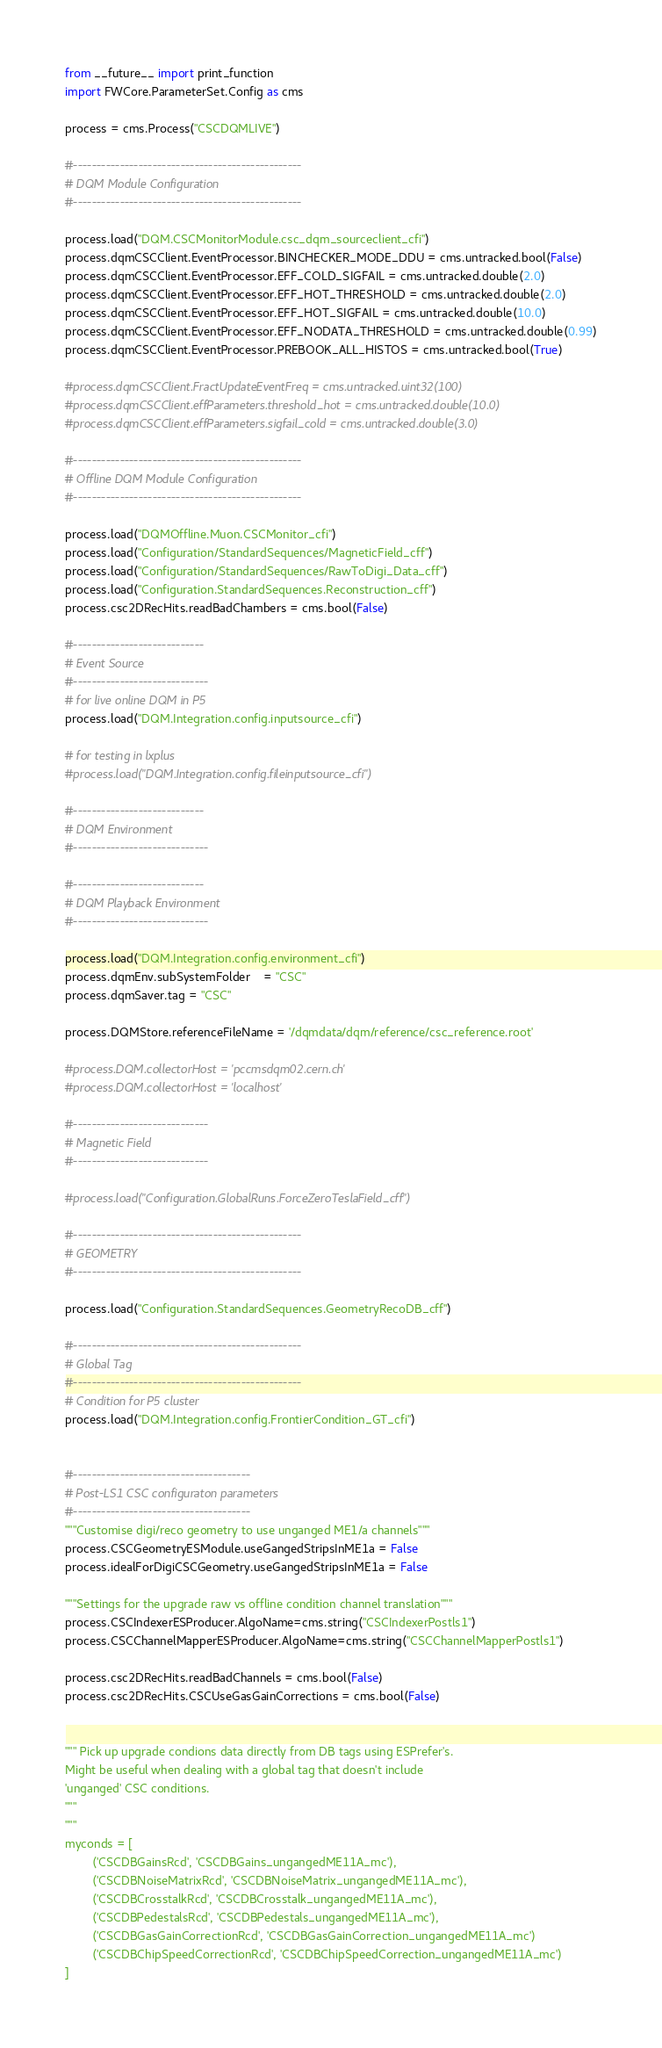<code> <loc_0><loc_0><loc_500><loc_500><_Python_>from __future__ import print_function
import FWCore.ParameterSet.Config as cms

process = cms.Process("CSCDQMLIVE")

#-------------------------------------------------
# DQM Module Configuration
#-------------------------------------------------

process.load("DQM.CSCMonitorModule.csc_dqm_sourceclient_cfi")
process.dqmCSCClient.EventProcessor.BINCHECKER_MODE_DDU = cms.untracked.bool(False)
process.dqmCSCClient.EventProcessor.EFF_COLD_SIGFAIL = cms.untracked.double(2.0)
process.dqmCSCClient.EventProcessor.EFF_HOT_THRESHOLD = cms.untracked.double(2.0)
process.dqmCSCClient.EventProcessor.EFF_HOT_SIGFAIL = cms.untracked.double(10.0)
process.dqmCSCClient.EventProcessor.EFF_NODATA_THRESHOLD = cms.untracked.double(0.99)
process.dqmCSCClient.EventProcessor.PREBOOK_ALL_HISTOS = cms.untracked.bool(True)

#process.dqmCSCClient.FractUpdateEventFreq = cms.untracked.uint32(100)
#process.dqmCSCClient.effParameters.threshold_hot = cms.untracked.double(10.0)
#process.dqmCSCClient.effParameters.sigfail_cold = cms.untracked.double(3.0)

#-------------------------------------------------
# Offline DQM Module Configuration
#-------------------------------------------------

process.load("DQMOffline.Muon.CSCMonitor_cfi")
process.load("Configuration/StandardSequences/MagneticField_cff")
process.load("Configuration/StandardSequences/RawToDigi_Data_cff")
process.load("Configuration.StandardSequences.Reconstruction_cff")
process.csc2DRecHits.readBadChambers = cms.bool(False)

#----------------------------
# Event Source
#-----------------------------
# for live online DQM in P5
process.load("DQM.Integration.config.inputsource_cfi")

# for testing in lxplus
#process.load("DQM.Integration.config.fileinputsource_cfi")

#----------------------------
# DQM Environment
#-----------------------------

#----------------------------
# DQM Playback Environment
#-----------------------------

process.load("DQM.Integration.config.environment_cfi")
process.dqmEnv.subSystemFolder    = "CSC"
process.dqmSaver.tag = "CSC"

process.DQMStore.referenceFileName = '/dqmdata/dqm/reference/csc_reference.root'

#process.DQM.collectorHost = 'pccmsdqm02.cern.ch'
#process.DQM.collectorHost = 'localhost'

#-----------------------------
# Magnetic Field
#-----------------------------

#process.load("Configuration.GlobalRuns.ForceZeroTeslaField_cff")

#-------------------------------------------------
# GEOMETRY
#-------------------------------------------------

process.load("Configuration.StandardSequences.GeometryRecoDB_cff")

#-------------------------------------------------
# Global Tag
#-------------------------------------------------
# Condition for P5 cluster
process.load("DQM.Integration.config.FrontierCondition_GT_cfi")


#--------------------------------------
# Post-LS1 CSC configuraton parameters
#--------------------------------------
"""Customise digi/reco geometry to use unganged ME1/a channels"""
process.CSCGeometryESModule.useGangedStripsInME1a = False
process.idealForDigiCSCGeometry.useGangedStripsInME1a = False

"""Settings for the upgrade raw vs offline condition channel translation"""
process.CSCIndexerESProducer.AlgoName=cms.string("CSCIndexerPostls1")
process.CSCChannelMapperESProducer.AlgoName=cms.string("CSCChannelMapperPostls1")

process.csc2DRecHits.readBadChannels = cms.bool(False)
process.csc2DRecHits.CSCUseGasGainCorrections = cms.bool(False)


""" Pick up upgrade condions data directly from DB tags using ESPrefer's.
Might be useful when dealing with a global tag that doesn't include
'unganged' CSC conditions.
"""
"""
myconds = [
        ('CSCDBGainsRcd', 'CSCDBGains_ungangedME11A_mc'),
        ('CSCDBNoiseMatrixRcd', 'CSCDBNoiseMatrix_ungangedME11A_mc'),
        ('CSCDBCrosstalkRcd', 'CSCDBCrosstalk_ungangedME11A_mc'),
        ('CSCDBPedestalsRcd', 'CSCDBPedestals_ungangedME11A_mc'),
        ('CSCDBGasGainCorrectionRcd', 'CSCDBGasGainCorrection_ungangedME11A_mc')
        ('CSCDBChipSpeedCorrectionRcd', 'CSCDBChipSpeedCorrection_ungangedME11A_mc')
]
</code> 